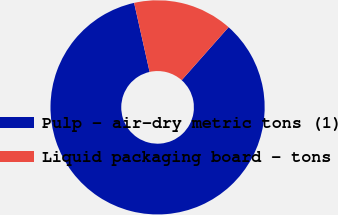Convert chart to OTSL. <chart><loc_0><loc_0><loc_500><loc_500><pie_chart><fcel>Pulp - air-dry metric tons (1)<fcel>Liquid packaging board - tons<nl><fcel>84.95%<fcel>15.05%<nl></chart> 